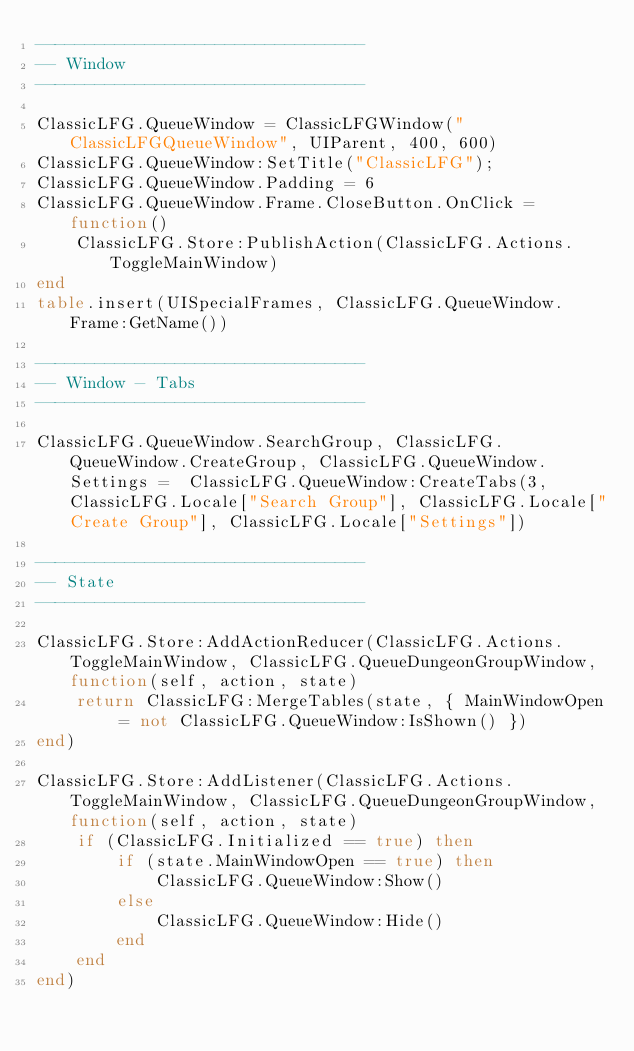Convert code to text. <code><loc_0><loc_0><loc_500><loc_500><_Lua_>---------------------------------
-- Window
---------------------------------

ClassicLFG.QueueWindow = ClassicLFGWindow("ClassicLFGQueueWindow", UIParent, 400, 600)
ClassicLFG.QueueWindow:SetTitle("ClassicLFG");
ClassicLFG.QueueWindow.Padding = 6
ClassicLFG.QueueWindow.Frame.CloseButton.OnClick = function()
    ClassicLFG.Store:PublishAction(ClassicLFG.Actions.ToggleMainWindow)
end
table.insert(UISpecialFrames, ClassicLFG.QueueWindow.Frame:GetName())

---------------------------------
-- Window - Tabs
---------------------------------

ClassicLFG.QueueWindow.SearchGroup, ClassicLFG.QueueWindow.CreateGroup, ClassicLFG.QueueWindow.Settings =  ClassicLFG.QueueWindow:CreateTabs(3, ClassicLFG.Locale["Search Group"], ClassicLFG.Locale["Create Group"], ClassicLFG.Locale["Settings"])

---------------------------------
-- State
---------------------------------

ClassicLFG.Store:AddActionReducer(ClassicLFG.Actions.ToggleMainWindow, ClassicLFG.QueueDungeonGroupWindow, function(self, action, state)
    return ClassicLFG:MergeTables(state, { MainWindowOpen = not ClassicLFG.QueueWindow:IsShown() })
end)

ClassicLFG.Store:AddListener(ClassicLFG.Actions.ToggleMainWindow, ClassicLFG.QueueDungeonGroupWindow, function(self, action, state)
    if (ClassicLFG.Initialized == true) then
        if (state.MainWindowOpen == true) then
            ClassicLFG.QueueWindow:Show()
        else
            ClassicLFG.QueueWindow:Hide()
        end
    end
end)</code> 